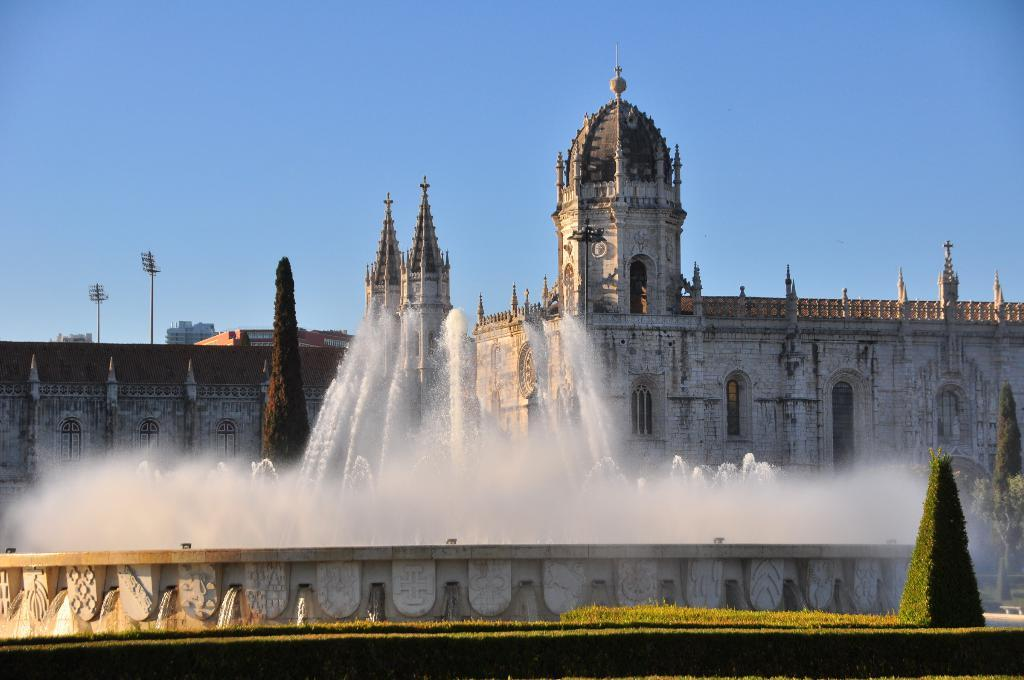What is the main structure in the image? There is a big building in the image. What is located in front of the building? There is a fountain in front of the building. What type of vegetation can be seen in the image? There are many plants in the image. What type of seed can be seen growing on the branch in the image? There is no branch or seed present in the image. How does the whistle sound in the image? There is no whistle present in the image. 